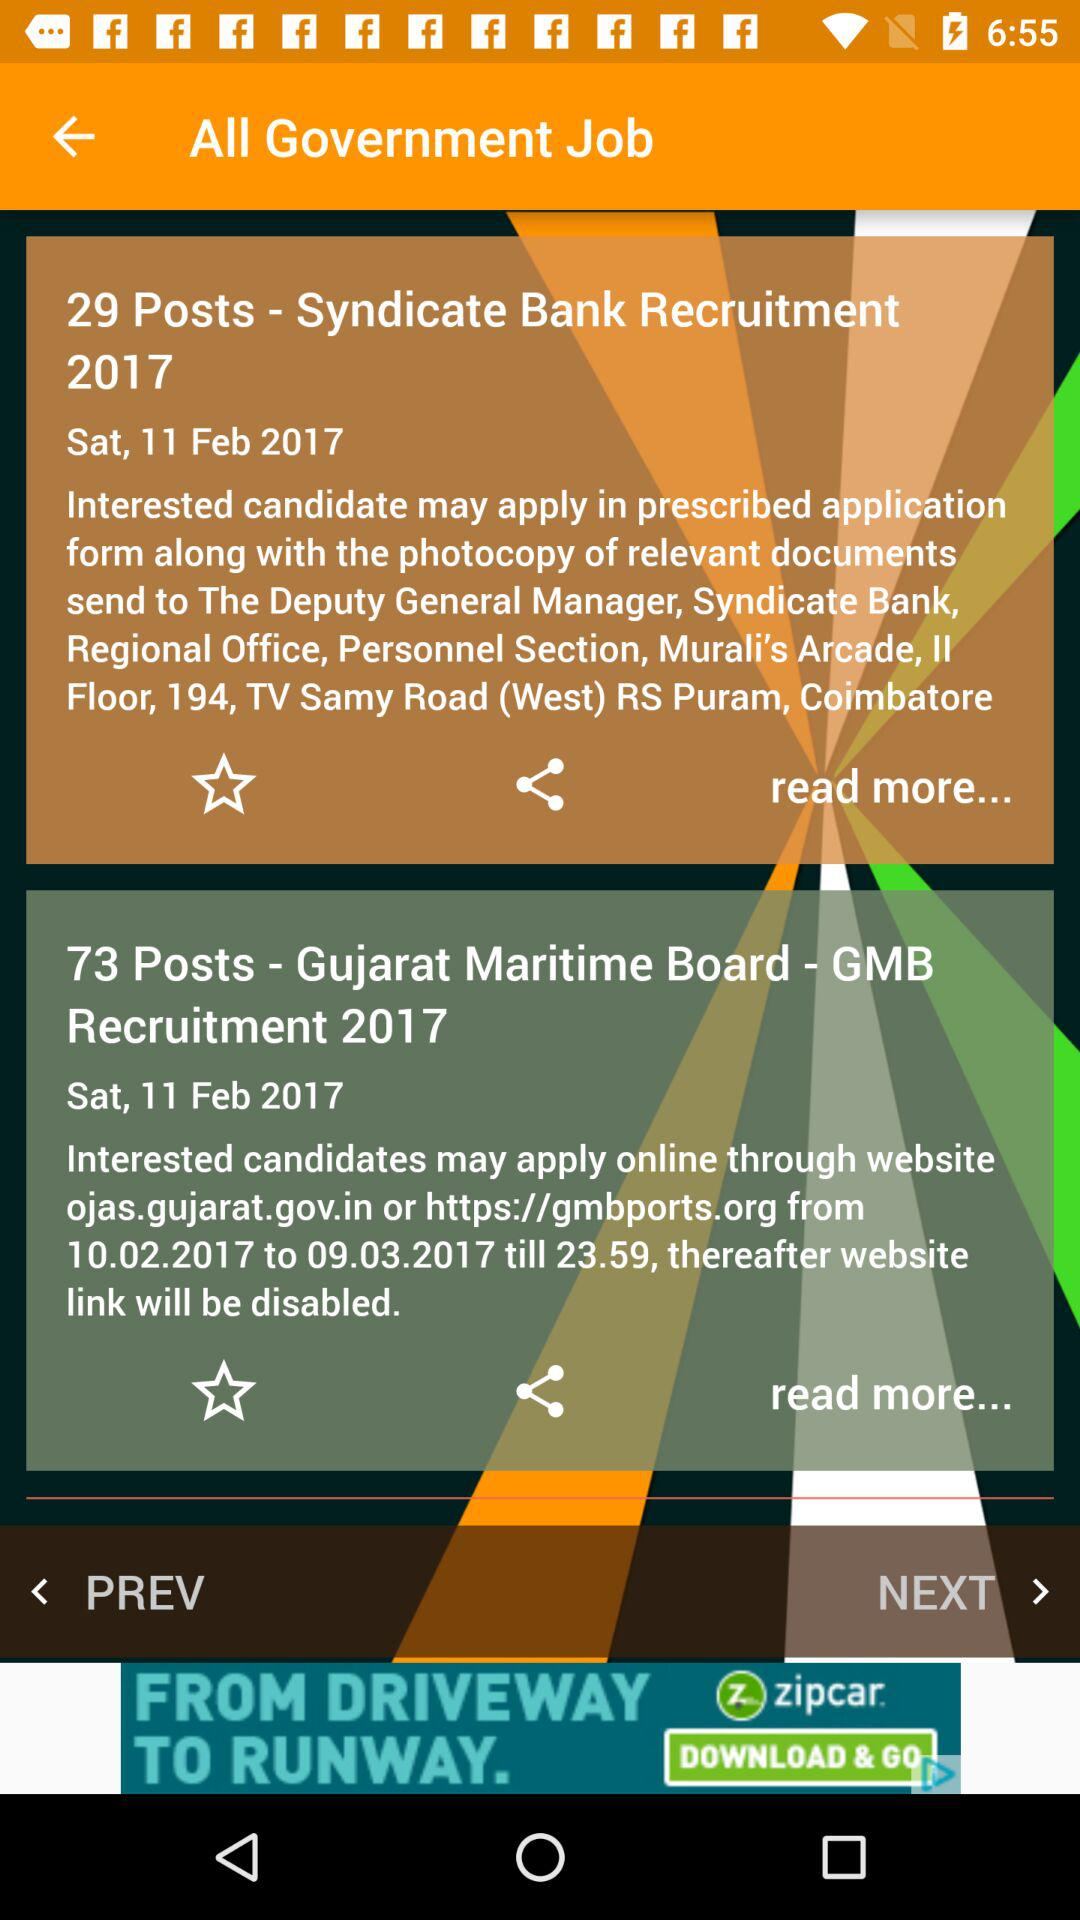How many posts are available in "Syndicate Bank" recruitment? There are 29 posts available in "Syndicate Bank" recruitment. 